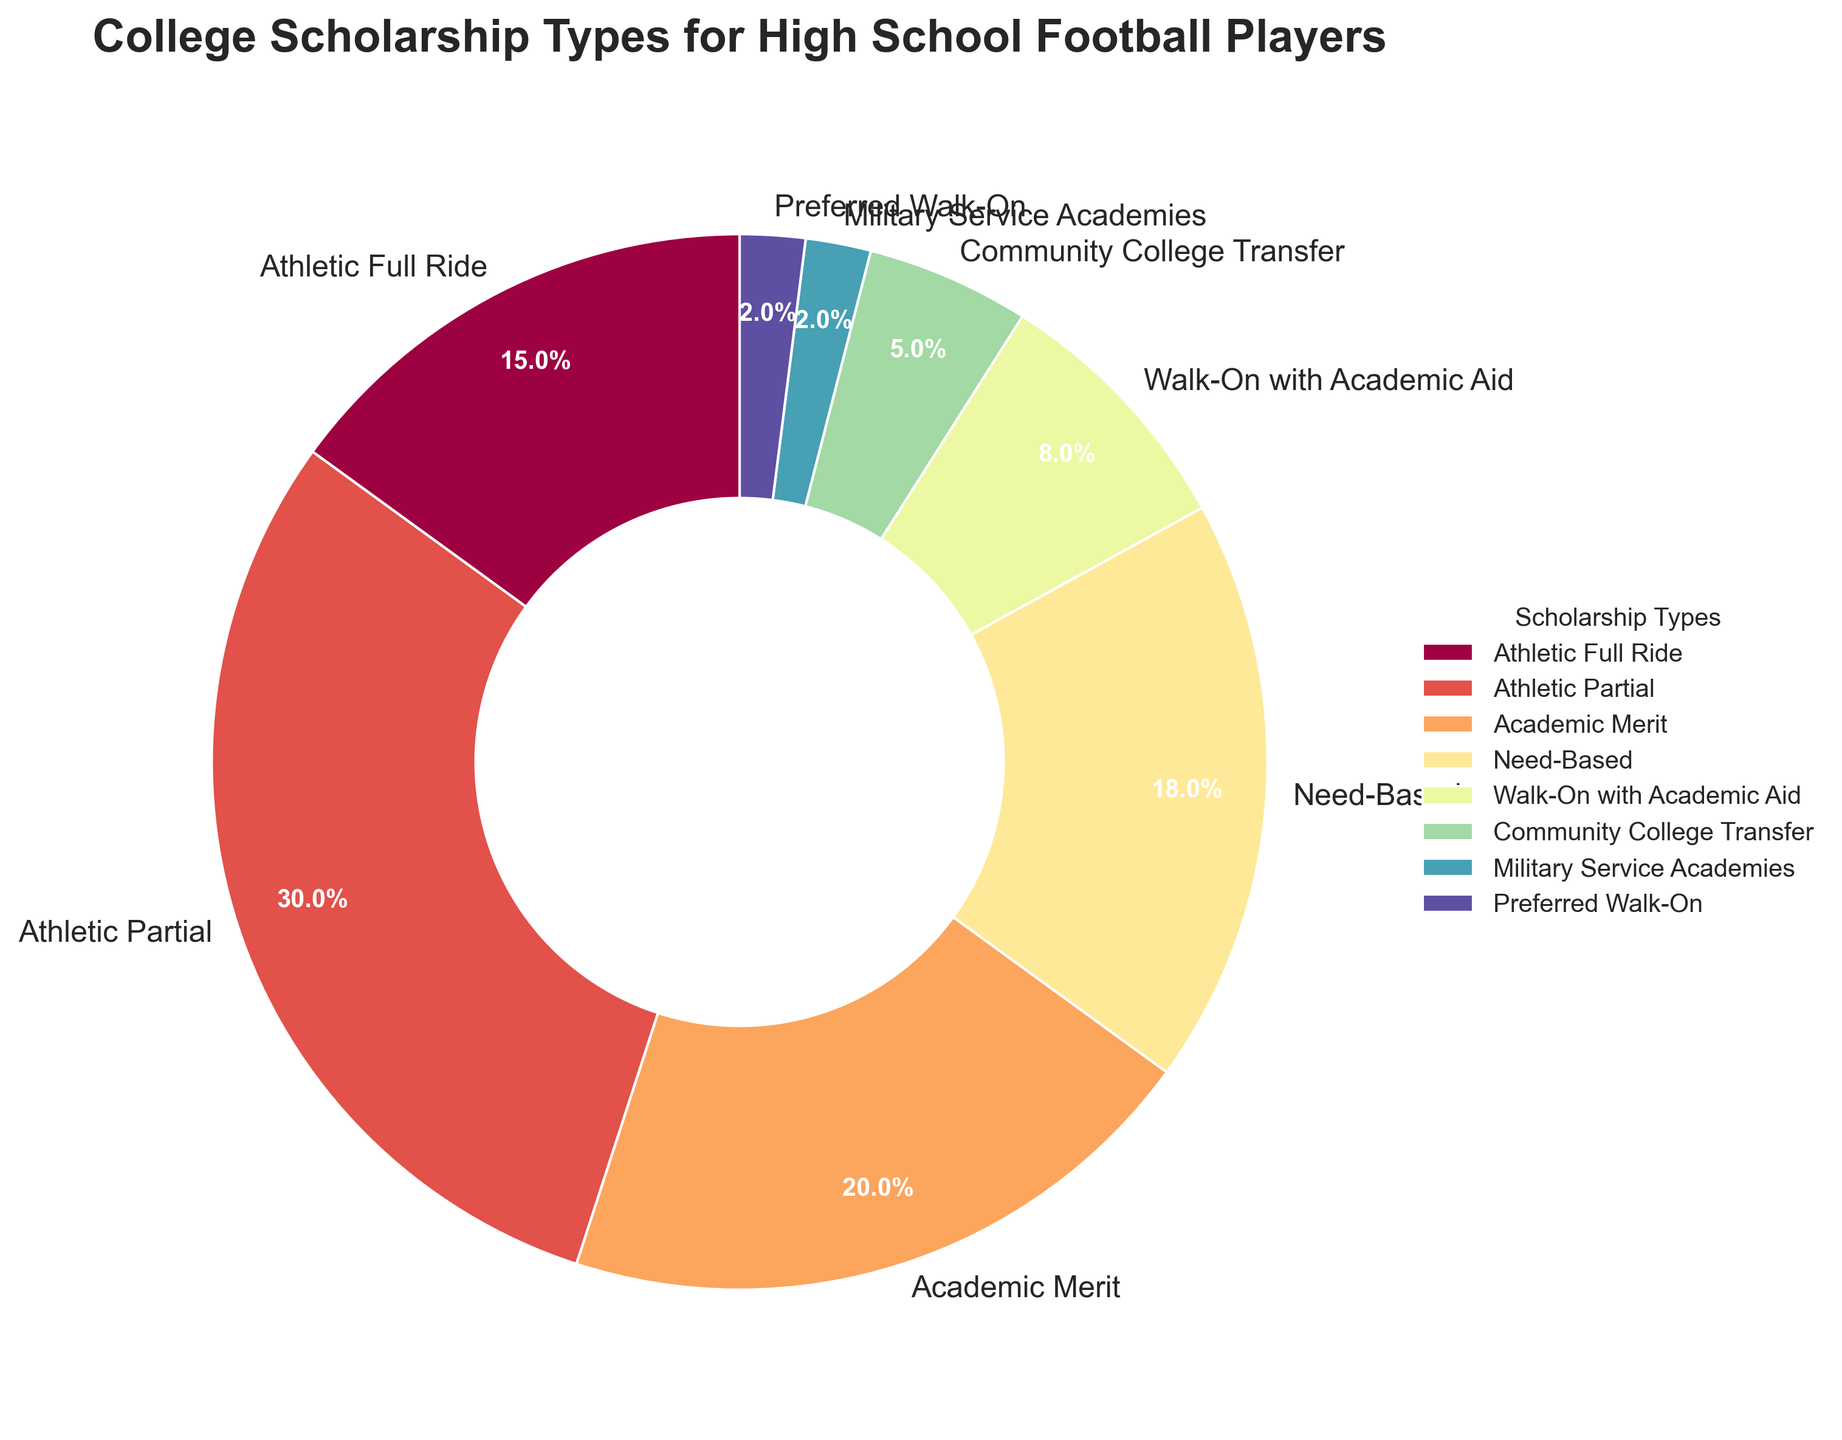What percentage of scholarships awarded are academic-related (Academic Merit and Walk-On with Academic Aid)? Sum the percentages for Academic Merit and Walk-On with Academic Aid: 20% + 8% = 28%.
Answer: 28% Which scholarship type has the smallest percentage? Identify the scholarship type with the lowest percentage value in the data table, which is Military Service Academies at 2%.
Answer: Military Service Academies What is the combined percentage of Athletic Full Ride and Athletic Partial scholarships? Add the percentages for Athletic Full Ride and Athletic Partial: 15% + 30% = 45%.
Answer: 45% How does the percentage of Need-Based scholarships compare to that of Community College Transfer scholarships? Compare the percentages: Need-Based is 18% and Community College Transfer is 5%, so Need-Based is greater.
Answer: Need-Based is greater What color represents the Walk-On with Academic Aid scholarships? Identify the color from the pie chart legend associated with Walk-On with Academic Aid.
Answer: Color from the legend (specific color depends on the chart) Which type of scholarship is awarded more frequently: Academic Merit or Need-Based? Compare the percentages: Academic Merit is 20% and Need-Based is 18%, so Academic Merit is awarded more frequently.
Answer: Academic Merit What is the average percentage for the three smallest scholarship types? Calculate the average of the three smallest percentages: (2% + 2% + 5%) / 3 = 3%.
Answer: 3% How many scholarship types are awarded at a rate of 10% or higher? Count the scholarship types that have percentages 10% or higher: Athletic Full Ride (15%), Athletic Partial (30%), Academic Merit (20%), Need-Based (18%). There are 4 such types.
Answer: 4 What percentage of scholarships are non-athletic (Academic Merit, Need-Based, Walk-On with Academic Aid, Community College Transfer)? Sum the percentages for the non-athletic scholarships: 20% + 18% + 8% + 5% = 51%.
Answer: 51% 